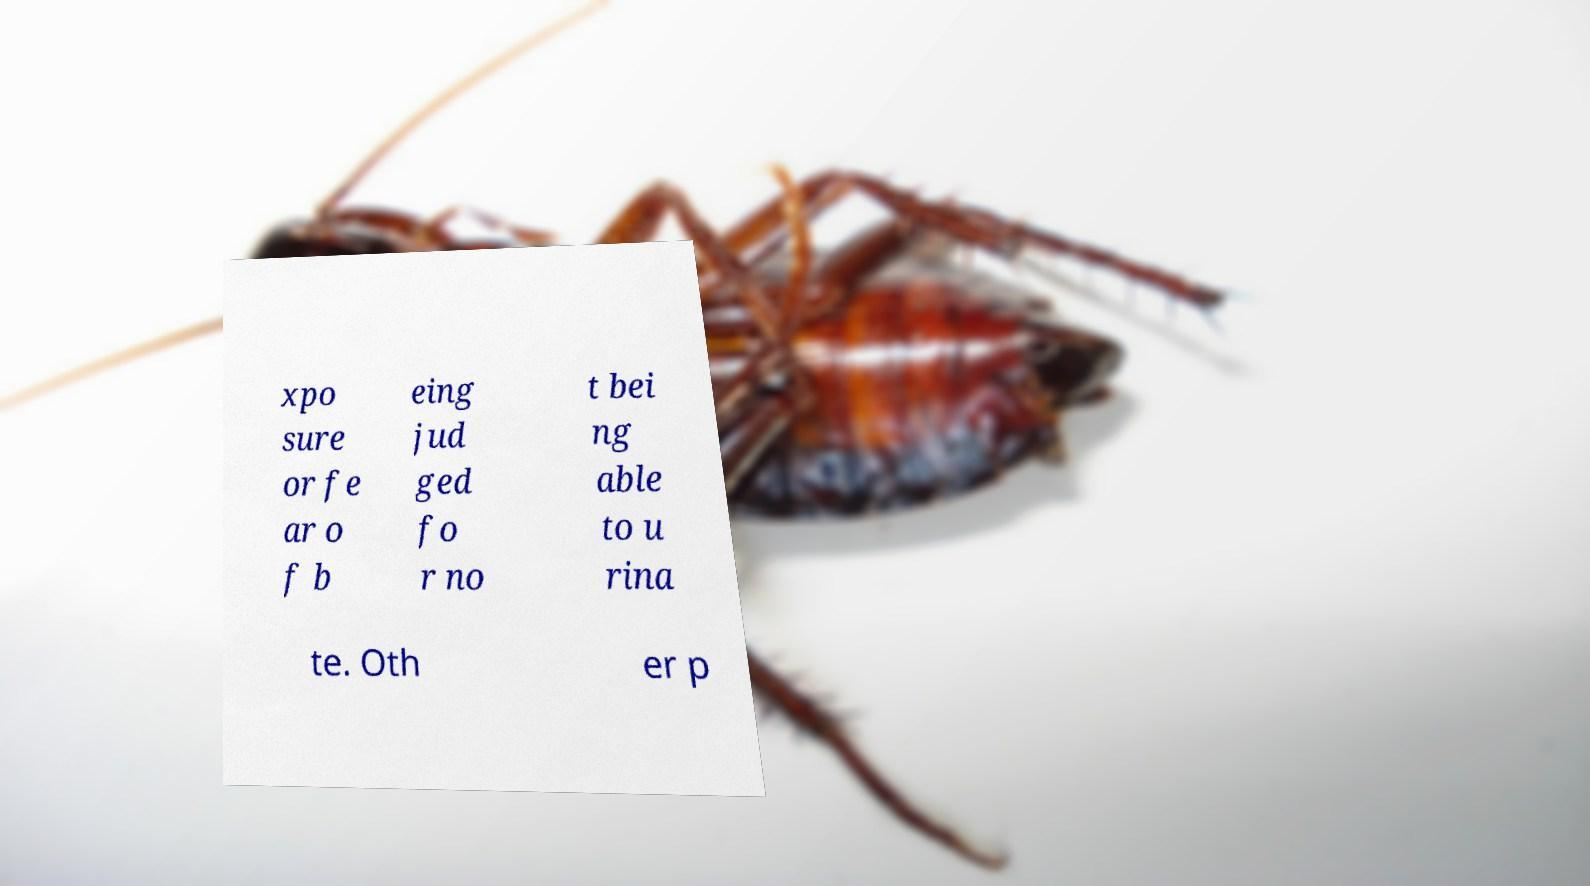Could you extract and type out the text from this image? xpo sure or fe ar o f b eing jud ged fo r no t bei ng able to u rina te. Oth er p 